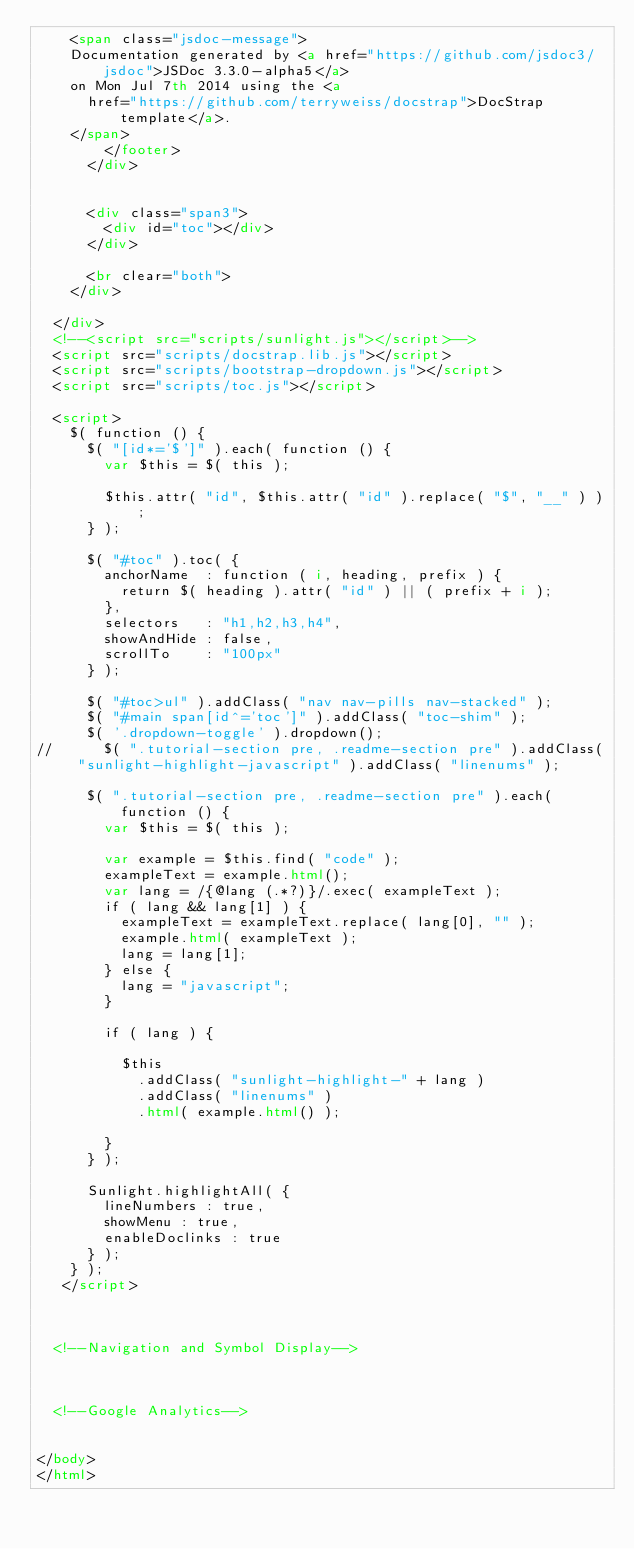<code> <loc_0><loc_0><loc_500><loc_500><_HTML_>		<span class="jsdoc-message">
		Documentation generated by <a href="https://github.com/jsdoc3/jsdoc">JSDoc 3.3.0-alpha5</a>
		on Mon Jul 7th 2014 using the <a
			href="https://github.com/terryweiss/docstrap">DocStrap template</a>.
		</span>
				</footer>
			</div>

			
			<div class="span3">
				<div id="toc"></div>
			</div>
			
			<br clear="both">
		</div>

	</div>
	<!--<script src="scripts/sunlight.js"></script>-->
	<script src="scripts/docstrap.lib.js"></script>
	<script src="scripts/bootstrap-dropdown.js"></script>
	<script src="scripts/toc.js"></script>

	<script>
		$( function () {
			$( "[id*='$']" ).each( function () {
				var $this = $( this );

				$this.attr( "id", $this.attr( "id" ).replace( "$", "__" ) );
			} );

			$( "#toc" ).toc( {
				anchorName  : function ( i, heading, prefix ) {
					return $( heading ).attr( "id" ) || ( prefix + i );
				},
				selectors   : "h1,h2,h3,h4",
				showAndHide : false,
				scrollTo    : "100px"
			} );

			$( "#toc>ul" ).addClass( "nav nav-pills nav-stacked" );
			$( "#main span[id^='toc']" ).addClass( "toc-shim" );
			$( '.dropdown-toggle' ).dropdown();
//			$( ".tutorial-section pre, .readme-section pre" ).addClass( "sunlight-highlight-javascript" ).addClass( "linenums" );

			$( ".tutorial-section pre, .readme-section pre" ).each( function () {
				var $this = $( this );

				var example = $this.find( "code" );
				exampleText = example.html();
				var lang = /{@lang (.*?)}/.exec( exampleText );
				if ( lang && lang[1] ) {
					exampleText = exampleText.replace( lang[0], "" );
					example.html( exampleText );
					lang = lang[1];
				} else {
					lang = "javascript";
				}

				if ( lang ) {

					$this
						.addClass( "sunlight-highlight-" + lang )
						.addClass( "linenums" )
						.html( example.html() );

				}
			} );

			Sunlight.highlightAll( {
				lineNumbers : true,
				showMenu : true,
				enableDoclinks : true
			} );
		} );
	 </script>



	<!--Navigation and Symbol Display-->
	


	<!--Google Analytics-->
	

</body>
</html></code> 